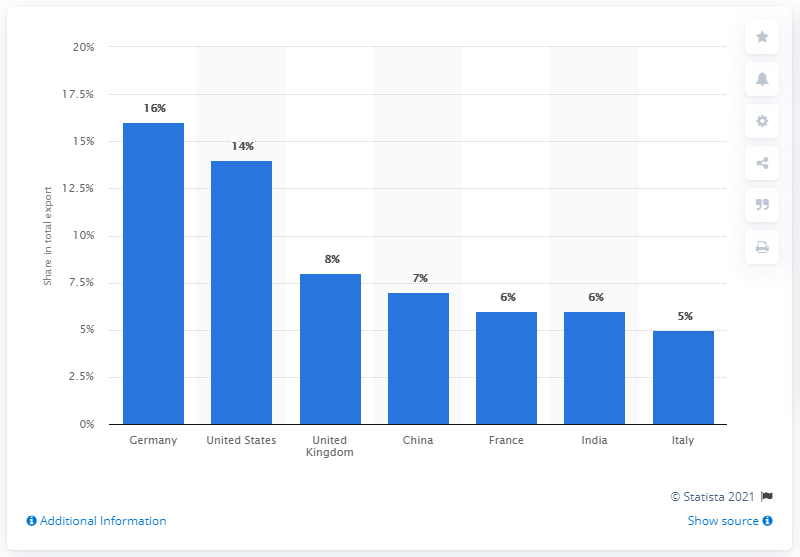Draw attention to some important aspects in this diagram. In 2019, Germany was the primary export partner of Switzerland. In 2019, the main export partner of Switzerland was Germany. 